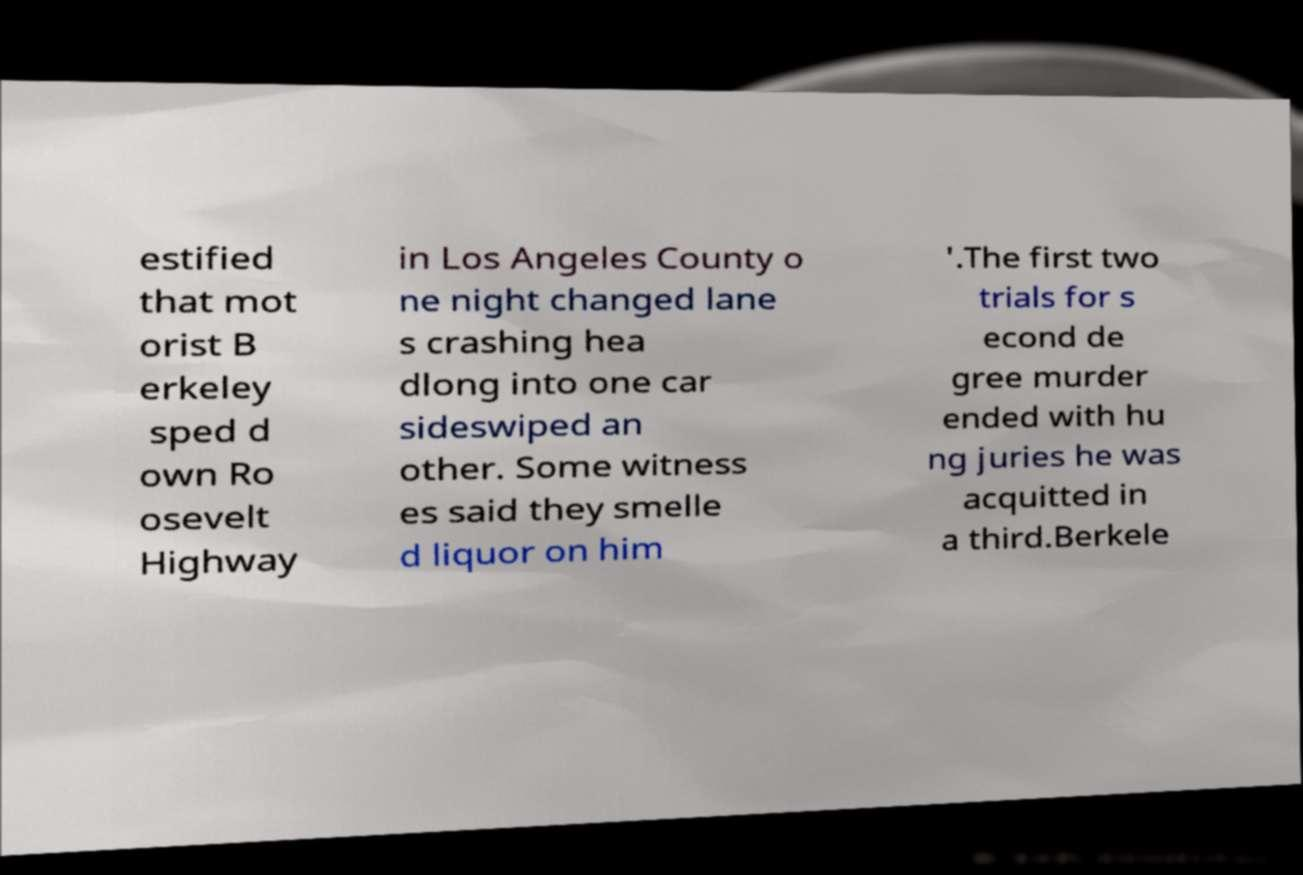I need the written content from this picture converted into text. Can you do that? estified that mot orist B erkeley sped d own Ro osevelt Highway in Los Angeles County o ne night changed lane s crashing hea dlong into one car sideswiped an other. Some witness es said they smelle d liquor on him '.The first two trials for s econd de gree murder ended with hu ng juries he was acquitted in a third.Berkele 